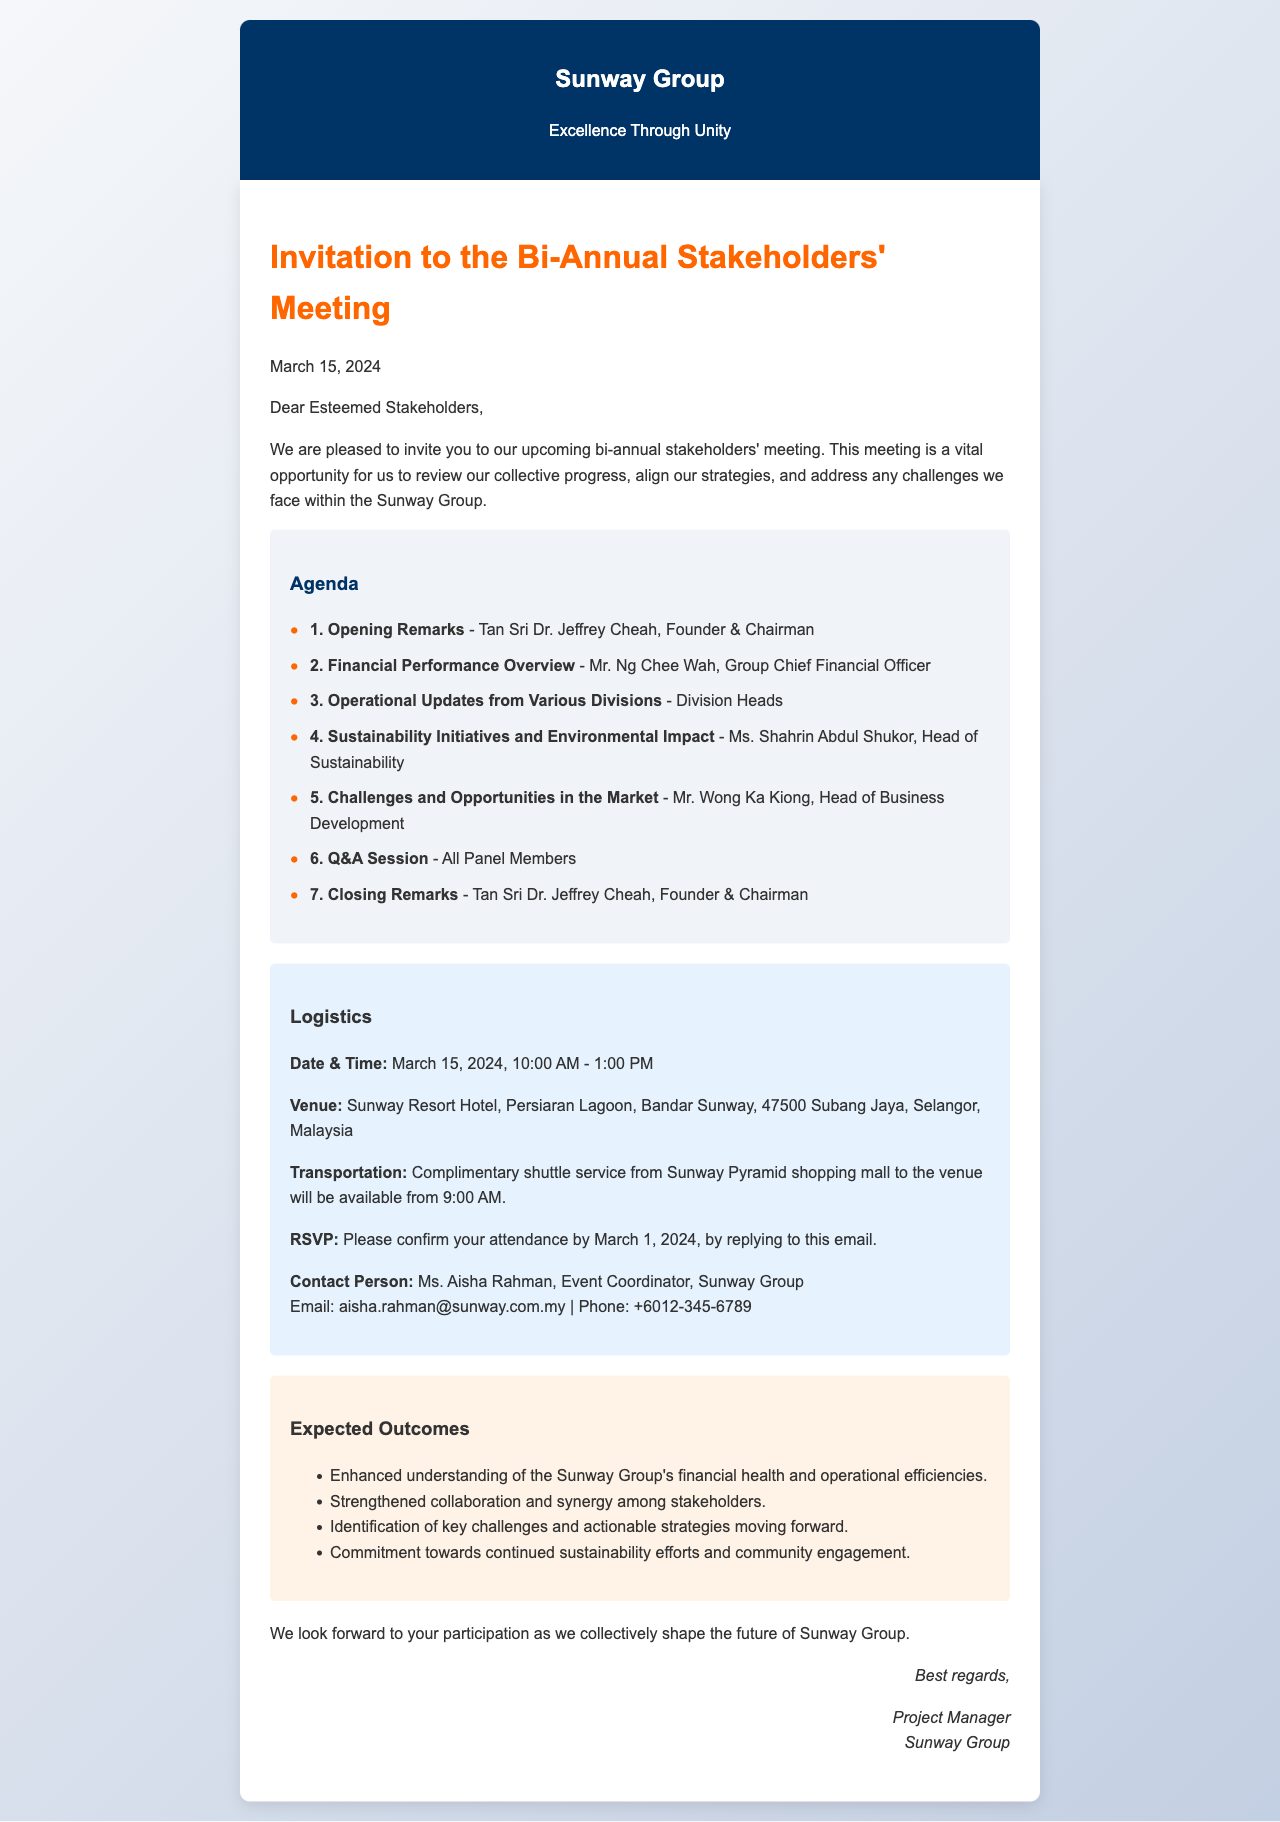What is the date of the meeting? The date of the meeting is mentioned clearly in the document as March 15, 2024.
Answer: March 15, 2024 Who is giving the opening remarks? The document states that Tan Sri Dr. Jeffrey Cheah, Founder & Chairman, will give the opening remarks.
Answer: Tan Sri Dr. Jeffrey Cheah What is the venue for the meeting? The venue is specified in the logistics section as the Sunway Resort Hotel in Subang Jaya, Selangor, Malaysia.
Answer: Sunway Resort Hotel What time does the meeting start? The logistics section details that the meeting starts at 10:00 AM.
Answer: 10:00 AM By what date should attendees RSVP? The document indicates that attendees should confirm their attendance by March 1, 2024.
Answer: March 1, 2024 What is one expected outcome of the meeting? The outcomes section lists several expected outcomes; one of them is an enhanced understanding of the Sunway Group's financial health.
Answer: Enhanced understanding of the Sunway Group's financial health How long is the duration of the meeting? The logistics section provides the start and end times, totaling a duration of 3 hours for the meeting.
Answer: 3 hours What mode of transportation is provided? The logistics section explains that a complimentary shuttle service is available from Sunway Pyramid shopping mall.
Answer: Complimentary shuttle service Who is the contact person for the event? The document identifies Ms. Aisha Rahman as the contact person for the event coordination.
Answer: Ms. Aisha Rahman 